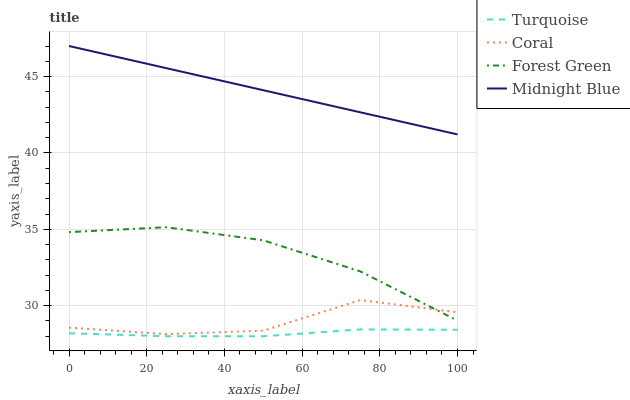Does Turquoise have the minimum area under the curve?
Answer yes or no. Yes. Does Midnight Blue have the maximum area under the curve?
Answer yes or no. Yes. Does Coral have the minimum area under the curve?
Answer yes or no. No. Does Coral have the maximum area under the curve?
Answer yes or no. No. Is Midnight Blue the smoothest?
Answer yes or no. Yes. Is Coral the roughest?
Answer yes or no. Yes. Is Turquoise the smoothest?
Answer yes or no. No. Is Turquoise the roughest?
Answer yes or no. No. Does Turquoise have the lowest value?
Answer yes or no. Yes. Does Coral have the lowest value?
Answer yes or no. No. Does Midnight Blue have the highest value?
Answer yes or no. Yes. Does Coral have the highest value?
Answer yes or no. No. Is Forest Green less than Midnight Blue?
Answer yes or no. Yes. Is Coral greater than Turquoise?
Answer yes or no. Yes. Does Forest Green intersect Coral?
Answer yes or no. Yes. Is Forest Green less than Coral?
Answer yes or no. No. Is Forest Green greater than Coral?
Answer yes or no. No. Does Forest Green intersect Midnight Blue?
Answer yes or no. No. 